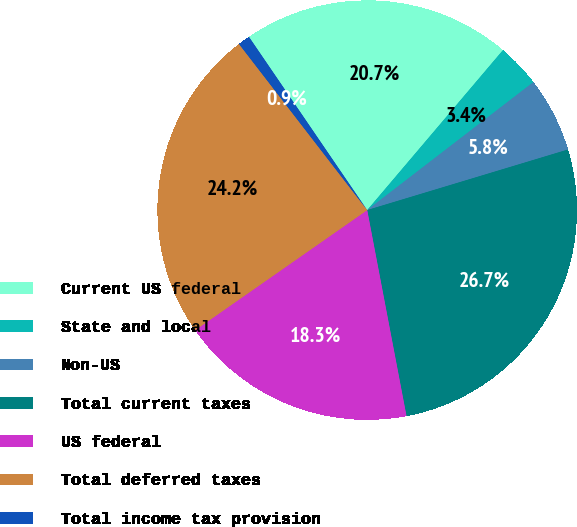<chart> <loc_0><loc_0><loc_500><loc_500><pie_chart><fcel>Current US federal<fcel>State and local<fcel>Non-US<fcel>Total current taxes<fcel>US federal<fcel>Total deferred taxes<fcel>Total income tax provision<nl><fcel>20.73%<fcel>3.36%<fcel>5.78%<fcel>26.66%<fcel>18.3%<fcel>24.24%<fcel>0.93%<nl></chart> 